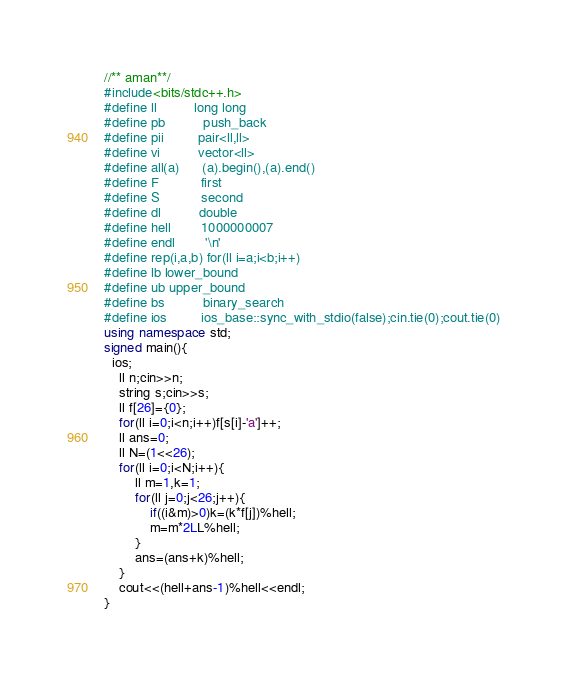Convert code to text. <code><loc_0><loc_0><loc_500><loc_500><_C++_>//** aman**/
#include<bits/stdc++.h>
#define ll          long long
#define pb          push_back
#define pii         pair<ll,ll>
#define vi          vector<ll>
#define all(a)      (a).begin(),(a).end()
#define F           first
#define S           second
#define dl          double
#define hell        1000000007
#define endl        '\n'
#define rep(i,a,b) for(ll i=a;i<b;i++)
#define lb lower_bound
#define ub upper_bound
#define bs          binary_search
#define ios         ios_base::sync_with_stdio(false);cin.tie(0);cout.tie(0)
using namespace std;
signed main(){
  ios;
	ll n;cin>>n;
	string s;cin>>s;
	ll f[26]={0};
	for(ll i=0;i<n;i++)f[s[i]-'a']++;
	ll ans=0;
	ll N=(1<<26);
	for(ll i=0;i<N;i++){
		ll m=1,k=1;
		for(ll j=0;j<26;j++){
			if((i&m)>0)k=(k*f[j])%hell;
			m=m*2LL%hell;
		}
		ans=(ans+k)%hell;
	}
	cout<<(hell+ans-1)%hell<<endl;
}</code> 